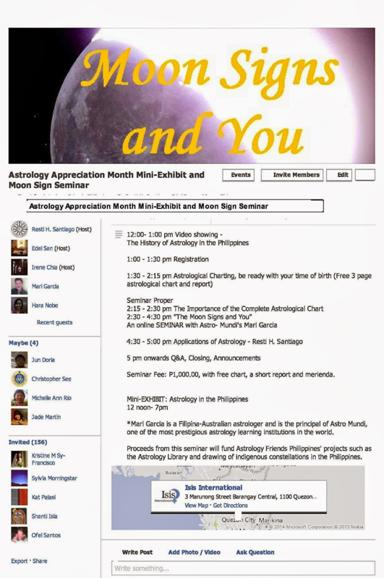What is the schedule of the seminar? The seminar schedule is packed with engaging segments, including a video presentation on the history of astrology in the Philippines from 12:00 - 1:00 pm, followed by a session on astrological chart registration. Detailed seminars on astrological charts and moon signs by experts, including Mari Garcia, run through the afternoon, concluding with a Q&A and announcements session from 5:00 pm onwards. 